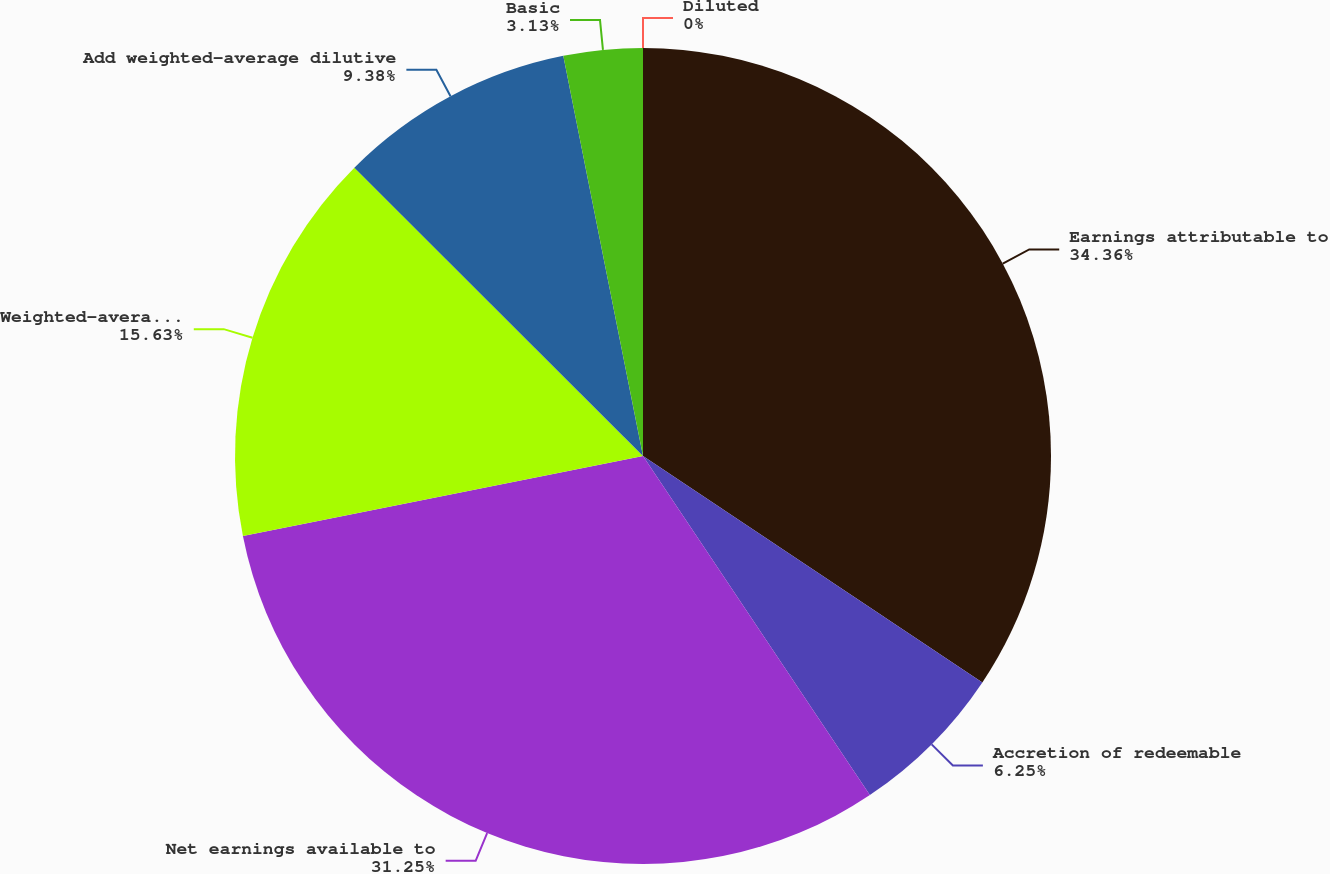Convert chart. <chart><loc_0><loc_0><loc_500><loc_500><pie_chart><fcel>Earnings attributable to<fcel>Accretion of redeemable<fcel>Net earnings available to<fcel>Weighted-average common shares<fcel>Add weighted-average dilutive<fcel>Basic<fcel>Diluted<nl><fcel>34.37%<fcel>6.25%<fcel>31.25%<fcel>15.63%<fcel>9.38%<fcel>3.13%<fcel>0.0%<nl></chart> 